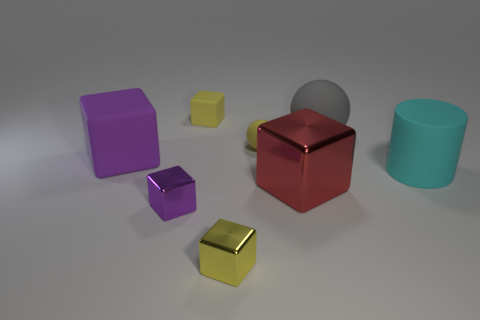Subtract all red cubes. How many cubes are left? 4 Subtract all large metal blocks. How many blocks are left? 4 Subtract all green blocks. Subtract all brown cylinders. How many blocks are left? 5 Add 2 big yellow metallic objects. How many objects exist? 10 Subtract all cubes. How many objects are left? 3 Add 1 large brown cubes. How many large brown cubes exist? 1 Subtract 2 yellow cubes. How many objects are left? 6 Subtract all purple cubes. Subtract all yellow things. How many objects are left? 3 Add 1 red metal objects. How many red metal objects are left? 2 